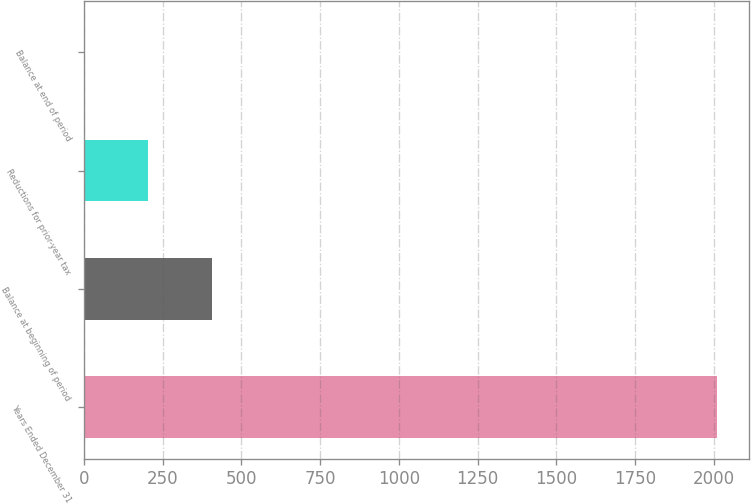Convert chart. <chart><loc_0><loc_0><loc_500><loc_500><bar_chart><fcel>Years Ended December 31<fcel>Balance at beginning of period<fcel>Reductions for prior-year tax<fcel>Balance at end of period<nl><fcel>2010<fcel>405.2<fcel>204.6<fcel>4<nl></chart> 